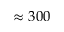<formula> <loc_0><loc_0><loc_500><loc_500>\approx 3 0 0</formula> 